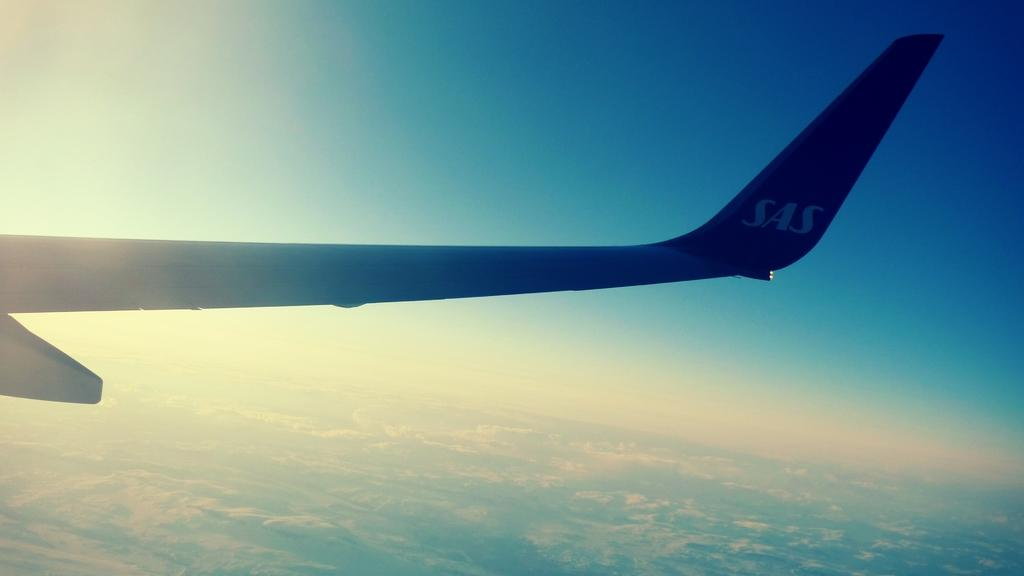<image>
Share a concise interpretation of the image provided. the wing of a plane with SAS on the side of it 